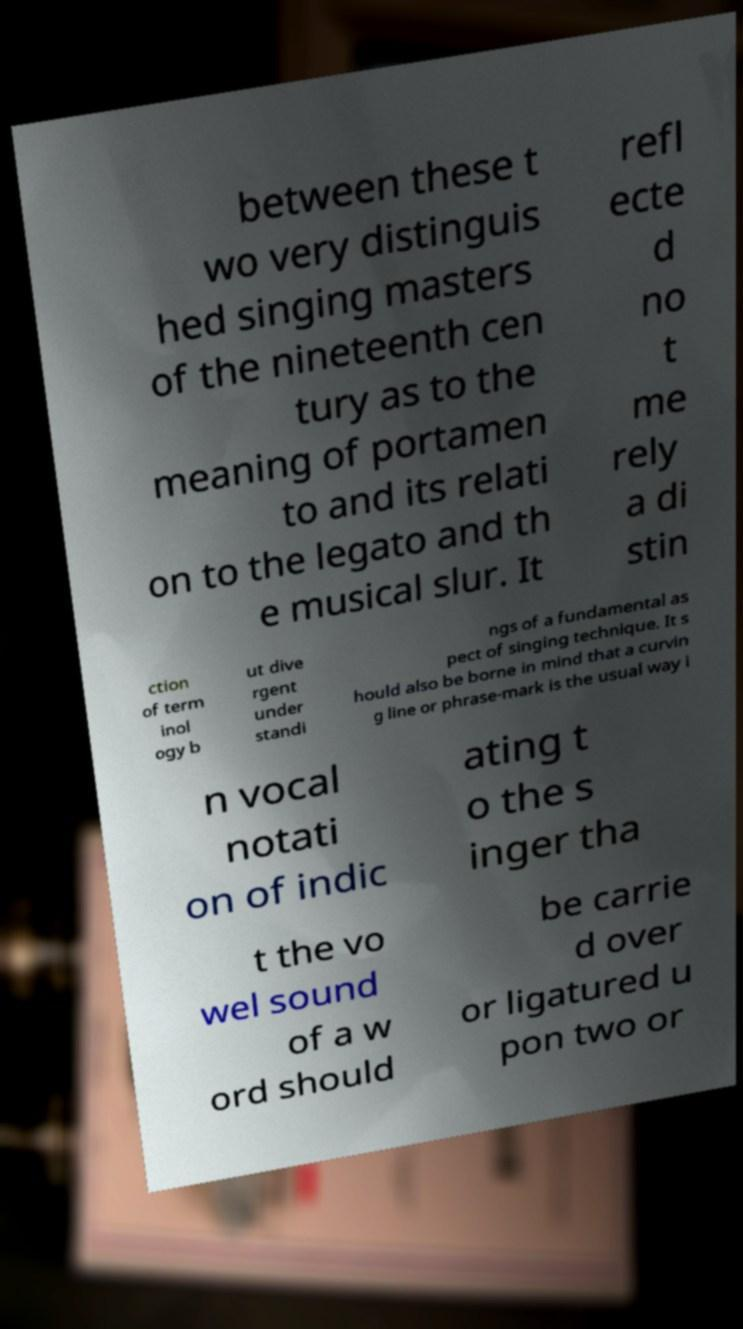What messages or text are displayed in this image? I need them in a readable, typed format. between these t wo very distinguis hed singing masters of the nineteenth cen tury as to the meaning of portamen to and its relati on to the legato and th e musical slur. It refl ecte d no t me rely a di stin ction of term inol ogy b ut dive rgent under standi ngs of a fundamental as pect of singing technique. It s hould also be borne in mind that a curvin g line or phrase-mark is the usual way i n vocal notati on of indic ating t o the s inger tha t the vo wel sound of a w ord should be carrie d over or ligatured u pon two or 